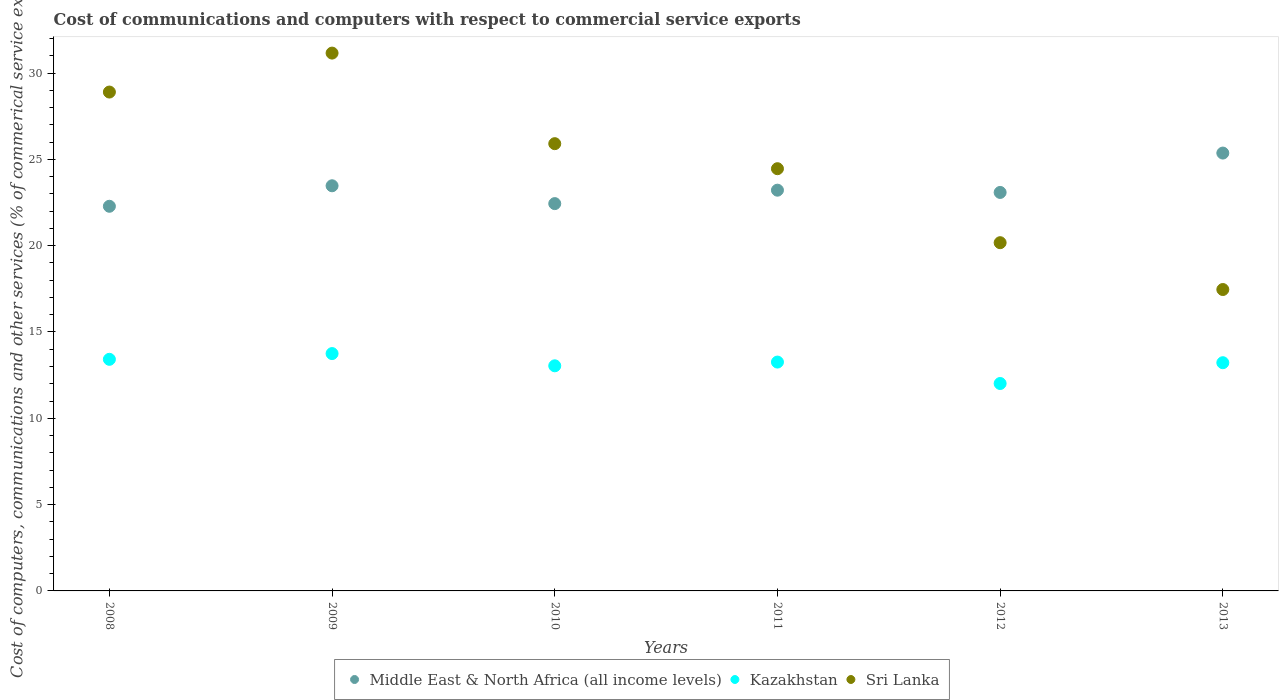Is the number of dotlines equal to the number of legend labels?
Provide a succinct answer. Yes. What is the cost of communications and computers in Kazakhstan in 2010?
Your answer should be very brief. 13.04. Across all years, what is the maximum cost of communications and computers in Sri Lanka?
Provide a short and direct response. 31.16. Across all years, what is the minimum cost of communications and computers in Kazakhstan?
Keep it short and to the point. 12.02. In which year was the cost of communications and computers in Sri Lanka minimum?
Make the answer very short. 2013. What is the total cost of communications and computers in Sri Lanka in the graph?
Ensure brevity in your answer.  148.05. What is the difference between the cost of communications and computers in Sri Lanka in 2010 and that in 2012?
Make the answer very short. 5.74. What is the difference between the cost of communications and computers in Middle East & North Africa (all income levels) in 2010 and the cost of communications and computers in Kazakhstan in 2008?
Keep it short and to the point. 9.02. What is the average cost of communications and computers in Kazakhstan per year?
Your answer should be compact. 13.12. In the year 2010, what is the difference between the cost of communications and computers in Sri Lanka and cost of communications and computers in Middle East & North Africa (all income levels)?
Offer a terse response. 3.47. What is the ratio of the cost of communications and computers in Middle East & North Africa (all income levels) in 2008 to that in 2009?
Your answer should be compact. 0.95. Is the difference between the cost of communications and computers in Sri Lanka in 2011 and 2012 greater than the difference between the cost of communications and computers in Middle East & North Africa (all income levels) in 2011 and 2012?
Offer a terse response. Yes. What is the difference between the highest and the second highest cost of communications and computers in Kazakhstan?
Your answer should be very brief. 0.33. What is the difference between the highest and the lowest cost of communications and computers in Sri Lanka?
Provide a succinct answer. 13.7. In how many years, is the cost of communications and computers in Kazakhstan greater than the average cost of communications and computers in Kazakhstan taken over all years?
Your answer should be very brief. 4. Is the sum of the cost of communications and computers in Kazakhstan in 2009 and 2013 greater than the maximum cost of communications and computers in Sri Lanka across all years?
Give a very brief answer. No. Is it the case that in every year, the sum of the cost of communications and computers in Sri Lanka and cost of communications and computers in Kazakhstan  is greater than the cost of communications and computers in Middle East & North Africa (all income levels)?
Ensure brevity in your answer.  Yes. Does the cost of communications and computers in Sri Lanka monotonically increase over the years?
Your answer should be very brief. No. Is the cost of communications and computers in Kazakhstan strictly greater than the cost of communications and computers in Middle East & North Africa (all income levels) over the years?
Ensure brevity in your answer.  No. Is the cost of communications and computers in Middle East & North Africa (all income levels) strictly less than the cost of communications and computers in Kazakhstan over the years?
Make the answer very short. No. How many dotlines are there?
Keep it short and to the point. 3. How many years are there in the graph?
Provide a short and direct response. 6. What is the difference between two consecutive major ticks on the Y-axis?
Your response must be concise. 5. Does the graph contain any zero values?
Ensure brevity in your answer.  No. What is the title of the graph?
Give a very brief answer. Cost of communications and computers with respect to commercial service exports. What is the label or title of the X-axis?
Give a very brief answer. Years. What is the label or title of the Y-axis?
Give a very brief answer. Cost of computers, communications and other services (% of commerical service exports). What is the Cost of computers, communications and other services (% of commerical service exports) of Middle East & North Africa (all income levels) in 2008?
Provide a succinct answer. 22.28. What is the Cost of computers, communications and other services (% of commerical service exports) in Kazakhstan in 2008?
Offer a very short reply. 13.42. What is the Cost of computers, communications and other services (% of commerical service exports) in Sri Lanka in 2008?
Your response must be concise. 28.9. What is the Cost of computers, communications and other services (% of commerical service exports) in Middle East & North Africa (all income levels) in 2009?
Provide a short and direct response. 23.47. What is the Cost of computers, communications and other services (% of commerical service exports) in Kazakhstan in 2009?
Make the answer very short. 13.75. What is the Cost of computers, communications and other services (% of commerical service exports) in Sri Lanka in 2009?
Provide a succinct answer. 31.16. What is the Cost of computers, communications and other services (% of commerical service exports) of Middle East & North Africa (all income levels) in 2010?
Ensure brevity in your answer.  22.44. What is the Cost of computers, communications and other services (% of commerical service exports) of Kazakhstan in 2010?
Provide a succinct answer. 13.04. What is the Cost of computers, communications and other services (% of commerical service exports) of Sri Lanka in 2010?
Keep it short and to the point. 25.91. What is the Cost of computers, communications and other services (% of commerical service exports) of Middle East & North Africa (all income levels) in 2011?
Make the answer very short. 23.21. What is the Cost of computers, communications and other services (% of commerical service exports) of Kazakhstan in 2011?
Give a very brief answer. 13.26. What is the Cost of computers, communications and other services (% of commerical service exports) of Sri Lanka in 2011?
Your answer should be compact. 24.46. What is the Cost of computers, communications and other services (% of commerical service exports) of Middle East & North Africa (all income levels) in 2012?
Offer a terse response. 23.08. What is the Cost of computers, communications and other services (% of commerical service exports) in Kazakhstan in 2012?
Your answer should be compact. 12.02. What is the Cost of computers, communications and other services (% of commerical service exports) in Sri Lanka in 2012?
Your answer should be very brief. 20.17. What is the Cost of computers, communications and other services (% of commerical service exports) of Middle East & North Africa (all income levels) in 2013?
Offer a terse response. 25.36. What is the Cost of computers, communications and other services (% of commerical service exports) of Kazakhstan in 2013?
Provide a short and direct response. 13.22. What is the Cost of computers, communications and other services (% of commerical service exports) of Sri Lanka in 2013?
Offer a terse response. 17.46. Across all years, what is the maximum Cost of computers, communications and other services (% of commerical service exports) in Middle East & North Africa (all income levels)?
Your answer should be compact. 25.36. Across all years, what is the maximum Cost of computers, communications and other services (% of commerical service exports) of Kazakhstan?
Your answer should be very brief. 13.75. Across all years, what is the maximum Cost of computers, communications and other services (% of commerical service exports) of Sri Lanka?
Offer a very short reply. 31.16. Across all years, what is the minimum Cost of computers, communications and other services (% of commerical service exports) of Middle East & North Africa (all income levels)?
Offer a terse response. 22.28. Across all years, what is the minimum Cost of computers, communications and other services (% of commerical service exports) in Kazakhstan?
Your answer should be very brief. 12.02. Across all years, what is the minimum Cost of computers, communications and other services (% of commerical service exports) in Sri Lanka?
Ensure brevity in your answer.  17.46. What is the total Cost of computers, communications and other services (% of commerical service exports) in Middle East & North Africa (all income levels) in the graph?
Provide a short and direct response. 139.85. What is the total Cost of computers, communications and other services (% of commerical service exports) of Kazakhstan in the graph?
Your response must be concise. 78.7. What is the total Cost of computers, communications and other services (% of commerical service exports) in Sri Lanka in the graph?
Ensure brevity in your answer.  148.05. What is the difference between the Cost of computers, communications and other services (% of commerical service exports) in Middle East & North Africa (all income levels) in 2008 and that in 2009?
Your answer should be very brief. -1.19. What is the difference between the Cost of computers, communications and other services (% of commerical service exports) in Kazakhstan in 2008 and that in 2009?
Keep it short and to the point. -0.33. What is the difference between the Cost of computers, communications and other services (% of commerical service exports) of Sri Lanka in 2008 and that in 2009?
Your response must be concise. -2.26. What is the difference between the Cost of computers, communications and other services (% of commerical service exports) in Middle East & North Africa (all income levels) in 2008 and that in 2010?
Your response must be concise. -0.15. What is the difference between the Cost of computers, communications and other services (% of commerical service exports) of Kazakhstan in 2008 and that in 2010?
Your response must be concise. 0.38. What is the difference between the Cost of computers, communications and other services (% of commerical service exports) in Sri Lanka in 2008 and that in 2010?
Your response must be concise. 2.99. What is the difference between the Cost of computers, communications and other services (% of commerical service exports) of Middle East & North Africa (all income levels) in 2008 and that in 2011?
Offer a very short reply. -0.93. What is the difference between the Cost of computers, communications and other services (% of commerical service exports) in Kazakhstan in 2008 and that in 2011?
Provide a succinct answer. 0.16. What is the difference between the Cost of computers, communications and other services (% of commerical service exports) in Sri Lanka in 2008 and that in 2011?
Your answer should be very brief. 4.44. What is the difference between the Cost of computers, communications and other services (% of commerical service exports) of Middle East & North Africa (all income levels) in 2008 and that in 2012?
Your answer should be compact. -0.8. What is the difference between the Cost of computers, communications and other services (% of commerical service exports) of Kazakhstan in 2008 and that in 2012?
Keep it short and to the point. 1.4. What is the difference between the Cost of computers, communications and other services (% of commerical service exports) of Sri Lanka in 2008 and that in 2012?
Make the answer very short. 8.73. What is the difference between the Cost of computers, communications and other services (% of commerical service exports) in Middle East & North Africa (all income levels) in 2008 and that in 2013?
Your answer should be compact. -3.08. What is the difference between the Cost of computers, communications and other services (% of commerical service exports) of Kazakhstan in 2008 and that in 2013?
Make the answer very short. 0.2. What is the difference between the Cost of computers, communications and other services (% of commerical service exports) in Sri Lanka in 2008 and that in 2013?
Your response must be concise. 11.44. What is the difference between the Cost of computers, communications and other services (% of commerical service exports) of Middle East & North Africa (all income levels) in 2009 and that in 2010?
Your answer should be very brief. 1.03. What is the difference between the Cost of computers, communications and other services (% of commerical service exports) of Kazakhstan in 2009 and that in 2010?
Make the answer very short. 0.71. What is the difference between the Cost of computers, communications and other services (% of commerical service exports) in Sri Lanka in 2009 and that in 2010?
Provide a short and direct response. 5.25. What is the difference between the Cost of computers, communications and other services (% of commerical service exports) in Middle East & North Africa (all income levels) in 2009 and that in 2011?
Keep it short and to the point. 0.25. What is the difference between the Cost of computers, communications and other services (% of commerical service exports) of Kazakhstan in 2009 and that in 2011?
Give a very brief answer. 0.49. What is the difference between the Cost of computers, communications and other services (% of commerical service exports) of Sri Lanka in 2009 and that in 2011?
Ensure brevity in your answer.  6.7. What is the difference between the Cost of computers, communications and other services (% of commerical service exports) of Middle East & North Africa (all income levels) in 2009 and that in 2012?
Keep it short and to the point. 0.39. What is the difference between the Cost of computers, communications and other services (% of commerical service exports) in Kazakhstan in 2009 and that in 2012?
Give a very brief answer. 1.73. What is the difference between the Cost of computers, communications and other services (% of commerical service exports) in Sri Lanka in 2009 and that in 2012?
Your response must be concise. 10.98. What is the difference between the Cost of computers, communications and other services (% of commerical service exports) in Middle East & North Africa (all income levels) in 2009 and that in 2013?
Provide a short and direct response. -1.89. What is the difference between the Cost of computers, communications and other services (% of commerical service exports) in Kazakhstan in 2009 and that in 2013?
Give a very brief answer. 0.53. What is the difference between the Cost of computers, communications and other services (% of commerical service exports) of Sri Lanka in 2009 and that in 2013?
Your answer should be very brief. 13.7. What is the difference between the Cost of computers, communications and other services (% of commerical service exports) of Middle East & North Africa (all income levels) in 2010 and that in 2011?
Give a very brief answer. -0.78. What is the difference between the Cost of computers, communications and other services (% of commerical service exports) of Kazakhstan in 2010 and that in 2011?
Keep it short and to the point. -0.22. What is the difference between the Cost of computers, communications and other services (% of commerical service exports) in Sri Lanka in 2010 and that in 2011?
Your answer should be compact. 1.45. What is the difference between the Cost of computers, communications and other services (% of commerical service exports) in Middle East & North Africa (all income levels) in 2010 and that in 2012?
Your answer should be compact. -0.65. What is the difference between the Cost of computers, communications and other services (% of commerical service exports) of Kazakhstan in 2010 and that in 2012?
Offer a terse response. 1.03. What is the difference between the Cost of computers, communications and other services (% of commerical service exports) of Sri Lanka in 2010 and that in 2012?
Make the answer very short. 5.74. What is the difference between the Cost of computers, communications and other services (% of commerical service exports) of Middle East & North Africa (all income levels) in 2010 and that in 2013?
Your response must be concise. -2.93. What is the difference between the Cost of computers, communications and other services (% of commerical service exports) of Kazakhstan in 2010 and that in 2013?
Your response must be concise. -0.18. What is the difference between the Cost of computers, communications and other services (% of commerical service exports) of Sri Lanka in 2010 and that in 2013?
Provide a succinct answer. 8.45. What is the difference between the Cost of computers, communications and other services (% of commerical service exports) of Middle East & North Africa (all income levels) in 2011 and that in 2012?
Your answer should be very brief. 0.13. What is the difference between the Cost of computers, communications and other services (% of commerical service exports) in Kazakhstan in 2011 and that in 2012?
Keep it short and to the point. 1.24. What is the difference between the Cost of computers, communications and other services (% of commerical service exports) in Sri Lanka in 2011 and that in 2012?
Give a very brief answer. 4.29. What is the difference between the Cost of computers, communications and other services (% of commerical service exports) of Middle East & North Africa (all income levels) in 2011 and that in 2013?
Give a very brief answer. -2.15. What is the difference between the Cost of computers, communications and other services (% of commerical service exports) in Kazakhstan in 2011 and that in 2013?
Provide a short and direct response. 0.04. What is the difference between the Cost of computers, communications and other services (% of commerical service exports) in Sri Lanka in 2011 and that in 2013?
Provide a short and direct response. 7. What is the difference between the Cost of computers, communications and other services (% of commerical service exports) in Middle East & North Africa (all income levels) in 2012 and that in 2013?
Give a very brief answer. -2.28. What is the difference between the Cost of computers, communications and other services (% of commerical service exports) of Kazakhstan in 2012 and that in 2013?
Your response must be concise. -1.2. What is the difference between the Cost of computers, communications and other services (% of commerical service exports) of Sri Lanka in 2012 and that in 2013?
Provide a succinct answer. 2.71. What is the difference between the Cost of computers, communications and other services (% of commerical service exports) in Middle East & North Africa (all income levels) in 2008 and the Cost of computers, communications and other services (% of commerical service exports) in Kazakhstan in 2009?
Offer a very short reply. 8.53. What is the difference between the Cost of computers, communications and other services (% of commerical service exports) in Middle East & North Africa (all income levels) in 2008 and the Cost of computers, communications and other services (% of commerical service exports) in Sri Lanka in 2009?
Your answer should be very brief. -8.87. What is the difference between the Cost of computers, communications and other services (% of commerical service exports) in Kazakhstan in 2008 and the Cost of computers, communications and other services (% of commerical service exports) in Sri Lanka in 2009?
Provide a short and direct response. -17.74. What is the difference between the Cost of computers, communications and other services (% of commerical service exports) of Middle East & North Africa (all income levels) in 2008 and the Cost of computers, communications and other services (% of commerical service exports) of Kazakhstan in 2010?
Offer a terse response. 9.24. What is the difference between the Cost of computers, communications and other services (% of commerical service exports) in Middle East & North Africa (all income levels) in 2008 and the Cost of computers, communications and other services (% of commerical service exports) in Sri Lanka in 2010?
Make the answer very short. -3.63. What is the difference between the Cost of computers, communications and other services (% of commerical service exports) of Kazakhstan in 2008 and the Cost of computers, communications and other services (% of commerical service exports) of Sri Lanka in 2010?
Make the answer very short. -12.49. What is the difference between the Cost of computers, communications and other services (% of commerical service exports) of Middle East & North Africa (all income levels) in 2008 and the Cost of computers, communications and other services (% of commerical service exports) of Kazakhstan in 2011?
Your response must be concise. 9.03. What is the difference between the Cost of computers, communications and other services (% of commerical service exports) of Middle East & North Africa (all income levels) in 2008 and the Cost of computers, communications and other services (% of commerical service exports) of Sri Lanka in 2011?
Keep it short and to the point. -2.18. What is the difference between the Cost of computers, communications and other services (% of commerical service exports) of Kazakhstan in 2008 and the Cost of computers, communications and other services (% of commerical service exports) of Sri Lanka in 2011?
Give a very brief answer. -11.04. What is the difference between the Cost of computers, communications and other services (% of commerical service exports) of Middle East & North Africa (all income levels) in 2008 and the Cost of computers, communications and other services (% of commerical service exports) of Kazakhstan in 2012?
Offer a very short reply. 10.27. What is the difference between the Cost of computers, communications and other services (% of commerical service exports) of Middle East & North Africa (all income levels) in 2008 and the Cost of computers, communications and other services (% of commerical service exports) of Sri Lanka in 2012?
Make the answer very short. 2.11. What is the difference between the Cost of computers, communications and other services (% of commerical service exports) of Kazakhstan in 2008 and the Cost of computers, communications and other services (% of commerical service exports) of Sri Lanka in 2012?
Your answer should be very brief. -6.76. What is the difference between the Cost of computers, communications and other services (% of commerical service exports) in Middle East & North Africa (all income levels) in 2008 and the Cost of computers, communications and other services (% of commerical service exports) in Kazakhstan in 2013?
Offer a very short reply. 9.06. What is the difference between the Cost of computers, communications and other services (% of commerical service exports) of Middle East & North Africa (all income levels) in 2008 and the Cost of computers, communications and other services (% of commerical service exports) of Sri Lanka in 2013?
Make the answer very short. 4.82. What is the difference between the Cost of computers, communications and other services (% of commerical service exports) of Kazakhstan in 2008 and the Cost of computers, communications and other services (% of commerical service exports) of Sri Lanka in 2013?
Provide a succinct answer. -4.04. What is the difference between the Cost of computers, communications and other services (% of commerical service exports) of Middle East & North Africa (all income levels) in 2009 and the Cost of computers, communications and other services (% of commerical service exports) of Kazakhstan in 2010?
Give a very brief answer. 10.43. What is the difference between the Cost of computers, communications and other services (% of commerical service exports) of Middle East & North Africa (all income levels) in 2009 and the Cost of computers, communications and other services (% of commerical service exports) of Sri Lanka in 2010?
Make the answer very short. -2.44. What is the difference between the Cost of computers, communications and other services (% of commerical service exports) of Kazakhstan in 2009 and the Cost of computers, communications and other services (% of commerical service exports) of Sri Lanka in 2010?
Your response must be concise. -12.16. What is the difference between the Cost of computers, communications and other services (% of commerical service exports) of Middle East & North Africa (all income levels) in 2009 and the Cost of computers, communications and other services (% of commerical service exports) of Kazakhstan in 2011?
Your answer should be very brief. 10.21. What is the difference between the Cost of computers, communications and other services (% of commerical service exports) in Middle East & North Africa (all income levels) in 2009 and the Cost of computers, communications and other services (% of commerical service exports) in Sri Lanka in 2011?
Your answer should be compact. -0.99. What is the difference between the Cost of computers, communications and other services (% of commerical service exports) of Kazakhstan in 2009 and the Cost of computers, communications and other services (% of commerical service exports) of Sri Lanka in 2011?
Provide a succinct answer. -10.71. What is the difference between the Cost of computers, communications and other services (% of commerical service exports) in Middle East & North Africa (all income levels) in 2009 and the Cost of computers, communications and other services (% of commerical service exports) in Kazakhstan in 2012?
Provide a short and direct response. 11.45. What is the difference between the Cost of computers, communications and other services (% of commerical service exports) of Middle East & North Africa (all income levels) in 2009 and the Cost of computers, communications and other services (% of commerical service exports) of Sri Lanka in 2012?
Offer a terse response. 3.3. What is the difference between the Cost of computers, communications and other services (% of commerical service exports) in Kazakhstan in 2009 and the Cost of computers, communications and other services (% of commerical service exports) in Sri Lanka in 2012?
Provide a succinct answer. -6.42. What is the difference between the Cost of computers, communications and other services (% of commerical service exports) in Middle East & North Africa (all income levels) in 2009 and the Cost of computers, communications and other services (% of commerical service exports) in Kazakhstan in 2013?
Offer a very short reply. 10.25. What is the difference between the Cost of computers, communications and other services (% of commerical service exports) of Middle East & North Africa (all income levels) in 2009 and the Cost of computers, communications and other services (% of commerical service exports) of Sri Lanka in 2013?
Your response must be concise. 6.01. What is the difference between the Cost of computers, communications and other services (% of commerical service exports) of Kazakhstan in 2009 and the Cost of computers, communications and other services (% of commerical service exports) of Sri Lanka in 2013?
Your answer should be compact. -3.71. What is the difference between the Cost of computers, communications and other services (% of commerical service exports) in Middle East & North Africa (all income levels) in 2010 and the Cost of computers, communications and other services (% of commerical service exports) in Kazakhstan in 2011?
Give a very brief answer. 9.18. What is the difference between the Cost of computers, communications and other services (% of commerical service exports) in Middle East & North Africa (all income levels) in 2010 and the Cost of computers, communications and other services (% of commerical service exports) in Sri Lanka in 2011?
Your answer should be very brief. -2.02. What is the difference between the Cost of computers, communications and other services (% of commerical service exports) in Kazakhstan in 2010 and the Cost of computers, communications and other services (% of commerical service exports) in Sri Lanka in 2011?
Ensure brevity in your answer.  -11.42. What is the difference between the Cost of computers, communications and other services (% of commerical service exports) of Middle East & North Africa (all income levels) in 2010 and the Cost of computers, communications and other services (% of commerical service exports) of Kazakhstan in 2012?
Your answer should be very brief. 10.42. What is the difference between the Cost of computers, communications and other services (% of commerical service exports) of Middle East & North Africa (all income levels) in 2010 and the Cost of computers, communications and other services (% of commerical service exports) of Sri Lanka in 2012?
Your response must be concise. 2.26. What is the difference between the Cost of computers, communications and other services (% of commerical service exports) in Kazakhstan in 2010 and the Cost of computers, communications and other services (% of commerical service exports) in Sri Lanka in 2012?
Keep it short and to the point. -7.13. What is the difference between the Cost of computers, communications and other services (% of commerical service exports) in Middle East & North Africa (all income levels) in 2010 and the Cost of computers, communications and other services (% of commerical service exports) in Kazakhstan in 2013?
Your response must be concise. 9.22. What is the difference between the Cost of computers, communications and other services (% of commerical service exports) in Middle East & North Africa (all income levels) in 2010 and the Cost of computers, communications and other services (% of commerical service exports) in Sri Lanka in 2013?
Your response must be concise. 4.98. What is the difference between the Cost of computers, communications and other services (% of commerical service exports) of Kazakhstan in 2010 and the Cost of computers, communications and other services (% of commerical service exports) of Sri Lanka in 2013?
Keep it short and to the point. -4.42. What is the difference between the Cost of computers, communications and other services (% of commerical service exports) of Middle East & North Africa (all income levels) in 2011 and the Cost of computers, communications and other services (% of commerical service exports) of Kazakhstan in 2012?
Provide a succinct answer. 11.2. What is the difference between the Cost of computers, communications and other services (% of commerical service exports) in Middle East & North Africa (all income levels) in 2011 and the Cost of computers, communications and other services (% of commerical service exports) in Sri Lanka in 2012?
Make the answer very short. 3.04. What is the difference between the Cost of computers, communications and other services (% of commerical service exports) of Kazakhstan in 2011 and the Cost of computers, communications and other services (% of commerical service exports) of Sri Lanka in 2012?
Your answer should be very brief. -6.92. What is the difference between the Cost of computers, communications and other services (% of commerical service exports) in Middle East & North Africa (all income levels) in 2011 and the Cost of computers, communications and other services (% of commerical service exports) in Kazakhstan in 2013?
Your answer should be compact. 9.99. What is the difference between the Cost of computers, communications and other services (% of commerical service exports) in Middle East & North Africa (all income levels) in 2011 and the Cost of computers, communications and other services (% of commerical service exports) in Sri Lanka in 2013?
Make the answer very short. 5.76. What is the difference between the Cost of computers, communications and other services (% of commerical service exports) in Kazakhstan in 2011 and the Cost of computers, communications and other services (% of commerical service exports) in Sri Lanka in 2013?
Your answer should be compact. -4.2. What is the difference between the Cost of computers, communications and other services (% of commerical service exports) of Middle East & North Africa (all income levels) in 2012 and the Cost of computers, communications and other services (% of commerical service exports) of Kazakhstan in 2013?
Offer a terse response. 9.86. What is the difference between the Cost of computers, communications and other services (% of commerical service exports) in Middle East & North Africa (all income levels) in 2012 and the Cost of computers, communications and other services (% of commerical service exports) in Sri Lanka in 2013?
Your answer should be very brief. 5.62. What is the difference between the Cost of computers, communications and other services (% of commerical service exports) of Kazakhstan in 2012 and the Cost of computers, communications and other services (% of commerical service exports) of Sri Lanka in 2013?
Your answer should be very brief. -5.44. What is the average Cost of computers, communications and other services (% of commerical service exports) of Middle East & North Africa (all income levels) per year?
Offer a very short reply. 23.31. What is the average Cost of computers, communications and other services (% of commerical service exports) of Kazakhstan per year?
Provide a succinct answer. 13.12. What is the average Cost of computers, communications and other services (% of commerical service exports) in Sri Lanka per year?
Your answer should be compact. 24.68. In the year 2008, what is the difference between the Cost of computers, communications and other services (% of commerical service exports) of Middle East & North Africa (all income levels) and Cost of computers, communications and other services (% of commerical service exports) of Kazakhstan?
Give a very brief answer. 8.87. In the year 2008, what is the difference between the Cost of computers, communications and other services (% of commerical service exports) in Middle East & North Africa (all income levels) and Cost of computers, communications and other services (% of commerical service exports) in Sri Lanka?
Keep it short and to the point. -6.62. In the year 2008, what is the difference between the Cost of computers, communications and other services (% of commerical service exports) of Kazakhstan and Cost of computers, communications and other services (% of commerical service exports) of Sri Lanka?
Provide a succinct answer. -15.48. In the year 2009, what is the difference between the Cost of computers, communications and other services (% of commerical service exports) in Middle East & North Africa (all income levels) and Cost of computers, communications and other services (% of commerical service exports) in Kazakhstan?
Provide a short and direct response. 9.72. In the year 2009, what is the difference between the Cost of computers, communications and other services (% of commerical service exports) in Middle East & North Africa (all income levels) and Cost of computers, communications and other services (% of commerical service exports) in Sri Lanka?
Offer a terse response. -7.69. In the year 2009, what is the difference between the Cost of computers, communications and other services (% of commerical service exports) in Kazakhstan and Cost of computers, communications and other services (% of commerical service exports) in Sri Lanka?
Your answer should be compact. -17.41. In the year 2010, what is the difference between the Cost of computers, communications and other services (% of commerical service exports) of Middle East & North Africa (all income levels) and Cost of computers, communications and other services (% of commerical service exports) of Kazakhstan?
Give a very brief answer. 9.4. In the year 2010, what is the difference between the Cost of computers, communications and other services (% of commerical service exports) in Middle East & North Africa (all income levels) and Cost of computers, communications and other services (% of commerical service exports) in Sri Lanka?
Provide a succinct answer. -3.47. In the year 2010, what is the difference between the Cost of computers, communications and other services (% of commerical service exports) in Kazakhstan and Cost of computers, communications and other services (% of commerical service exports) in Sri Lanka?
Keep it short and to the point. -12.87. In the year 2011, what is the difference between the Cost of computers, communications and other services (% of commerical service exports) in Middle East & North Africa (all income levels) and Cost of computers, communications and other services (% of commerical service exports) in Kazakhstan?
Provide a succinct answer. 9.96. In the year 2011, what is the difference between the Cost of computers, communications and other services (% of commerical service exports) of Middle East & North Africa (all income levels) and Cost of computers, communications and other services (% of commerical service exports) of Sri Lanka?
Provide a short and direct response. -1.24. In the year 2011, what is the difference between the Cost of computers, communications and other services (% of commerical service exports) in Kazakhstan and Cost of computers, communications and other services (% of commerical service exports) in Sri Lanka?
Offer a very short reply. -11.2. In the year 2012, what is the difference between the Cost of computers, communications and other services (% of commerical service exports) in Middle East & North Africa (all income levels) and Cost of computers, communications and other services (% of commerical service exports) in Kazakhstan?
Provide a succinct answer. 11.07. In the year 2012, what is the difference between the Cost of computers, communications and other services (% of commerical service exports) in Middle East & North Africa (all income levels) and Cost of computers, communications and other services (% of commerical service exports) in Sri Lanka?
Offer a terse response. 2.91. In the year 2012, what is the difference between the Cost of computers, communications and other services (% of commerical service exports) in Kazakhstan and Cost of computers, communications and other services (% of commerical service exports) in Sri Lanka?
Ensure brevity in your answer.  -8.16. In the year 2013, what is the difference between the Cost of computers, communications and other services (% of commerical service exports) of Middle East & North Africa (all income levels) and Cost of computers, communications and other services (% of commerical service exports) of Kazakhstan?
Offer a terse response. 12.14. In the year 2013, what is the difference between the Cost of computers, communications and other services (% of commerical service exports) of Middle East & North Africa (all income levels) and Cost of computers, communications and other services (% of commerical service exports) of Sri Lanka?
Provide a succinct answer. 7.9. In the year 2013, what is the difference between the Cost of computers, communications and other services (% of commerical service exports) in Kazakhstan and Cost of computers, communications and other services (% of commerical service exports) in Sri Lanka?
Give a very brief answer. -4.24. What is the ratio of the Cost of computers, communications and other services (% of commerical service exports) of Middle East & North Africa (all income levels) in 2008 to that in 2009?
Give a very brief answer. 0.95. What is the ratio of the Cost of computers, communications and other services (% of commerical service exports) in Kazakhstan in 2008 to that in 2009?
Provide a succinct answer. 0.98. What is the ratio of the Cost of computers, communications and other services (% of commerical service exports) in Sri Lanka in 2008 to that in 2009?
Give a very brief answer. 0.93. What is the ratio of the Cost of computers, communications and other services (% of commerical service exports) of Kazakhstan in 2008 to that in 2010?
Ensure brevity in your answer.  1.03. What is the ratio of the Cost of computers, communications and other services (% of commerical service exports) in Sri Lanka in 2008 to that in 2010?
Your answer should be very brief. 1.12. What is the ratio of the Cost of computers, communications and other services (% of commerical service exports) in Middle East & North Africa (all income levels) in 2008 to that in 2011?
Provide a succinct answer. 0.96. What is the ratio of the Cost of computers, communications and other services (% of commerical service exports) in Kazakhstan in 2008 to that in 2011?
Your answer should be compact. 1.01. What is the ratio of the Cost of computers, communications and other services (% of commerical service exports) in Sri Lanka in 2008 to that in 2011?
Provide a succinct answer. 1.18. What is the ratio of the Cost of computers, communications and other services (% of commerical service exports) of Middle East & North Africa (all income levels) in 2008 to that in 2012?
Make the answer very short. 0.97. What is the ratio of the Cost of computers, communications and other services (% of commerical service exports) in Kazakhstan in 2008 to that in 2012?
Make the answer very short. 1.12. What is the ratio of the Cost of computers, communications and other services (% of commerical service exports) in Sri Lanka in 2008 to that in 2012?
Your answer should be compact. 1.43. What is the ratio of the Cost of computers, communications and other services (% of commerical service exports) of Middle East & North Africa (all income levels) in 2008 to that in 2013?
Keep it short and to the point. 0.88. What is the ratio of the Cost of computers, communications and other services (% of commerical service exports) of Kazakhstan in 2008 to that in 2013?
Offer a very short reply. 1.01. What is the ratio of the Cost of computers, communications and other services (% of commerical service exports) in Sri Lanka in 2008 to that in 2013?
Your answer should be compact. 1.66. What is the ratio of the Cost of computers, communications and other services (% of commerical service exports) of Middle East & North Africa (all income levels) in 2009 to that in 2010?
Your answer should be compact. 1.05. What is the ratio of the Cost of computers, communications and other services (% of commerical service exports) in Kazakhstan in 2009 to that in 2010?
Make the answer very short. 1.05. What is the ratio of the Cost of computers, communications and other services (% of commerical service exports) of Sri Lanka in 2009 to that in 2010?
Make the answer very short. 1.2. What is the ratio of the Cost of computers, communications and other services (% of commerical service exports) of Middle East & North Africa (all income levels) in 2009 to that in 2011?
Offer a terse response. 1.01. What is the ratio of the Cost of computers, communications and other services (% of commerical service exports) in Kazakhstan in 2009 to that in 2011?
Provide a succinct answer. 1.04. What is the ratio of the Cost of computers, communications and other services (% of commerical service exports) in Sri Lanka in 2009 to that in 2011?
Offer a terse response. 1.27. What is the ratio of the Cost of computers, communications and other services (% of commerical service exports) of Middle East & North Africa (all income levels) in 2009 to that in 2012?
Keep it short and to the point. 1.02. What is the ratio of the Cost of computers, communications and other services (% of commerical service exports) of Kazakhstan in 2009 to that in 2012?
Your response must be concise. 1.14. What is the ratio of the Cost of computers, communications and other services (% of commerical service exports) of Sri Lanka in 2009 to that in 2012?
Make the answer very short. 1.54. What is the ratio of the Cost of computers, communications and other services (% of commerical service exports) of Middle East & North Africa (all income levels) in 2009 to that in 2013?
Provide a short and direct response. 0.93. What is the ratio of the Cost of computers, communications and other services (% of commerical service exports) in Sri Lanka in 2009 to that in 2013?
Your answer should be compact. 1.78. What is the ratio of the Cost of computers, communications and other services (% of commerical service exports) of Middle East & North Africa (all income levels) in 2010 to that in 2011?
Offer a terse response. 0.97. What is the ratio of the Cost of computers, communications and other services (% of commerical service exports) in Kazakhstan in 2010 to that in 2011?
Offer a very short reply. 0.98. What is the ratio of the Cost of computers, communications and other services (% of commerical service exports) of Sri Lanka in 2010 to that in 2011?
Keep it short and to the point. 1.06. What is the ratio of the Cost of computers, communications and other services (% of commerical service exports) in Middle East & North Africa (all income levels) in 2010 to that in 2012?
Offer a terse response. 0.97. What is the ratio of the Cost of computers, communications and other services (% of commerical service exports) in Kazakhstan in 2010 to that in 2012?
Offer a terse response. 1.09. What is the ratio of the Cost of computers, communications and other services (% of commerical service exports) in Sri Lanka in 2010 to that in 2012?
Offer a terse response. 1.28. What is the ratio of the Cost of computers, communications and other services (% of commerical service exports) of Middle East & North Africa (all income levels) in 2010 to that in 2013?
Make the answer very short. 0.88. What is the ratio of the Cost of computers, communications and other services (% of commerical service exports) in Kazakhstan in 2010 to that in 2013?
Offer a very short reply. 0.99. What is the ratio of the Cost of computers, communications and other services (% of commerical service exports) of Sri Lanka in 2010 to that in 2013?
Your answer should be very brief. 1.48. What is the ratio of the Cost of computers, communications and other services (% of commerical service exports) of Middle East & North Africa (all income levels) in 2011 to that in 2012?
Your response must be concise. 1.01. What is the ratio of the Cost of computers, communications and other services (% of commerical service exports) in Kazakhstan in 2011 to that in 2012?
Your answer should be very brief. 1.1. What is the ratio of the Cost of computers, communications and other services (% of commerical service exports) of Sri Lanka in 2011 to that in 2012?
Your response must be concise. 1.21. What is the ratio of the Cost of computers, communications and other services (% of commerical service exports) of Middle East & North Africa (all income levels) in 2011 to that in 2013?
Provide a succinct answer. 0.92. What is the ratio of the Cost of computers, communications and other services (% of commerical service exports) in Sri Lanka in 2011 to that in 2013?
Offer a very short reply. 1.4. What is the ratio of the Cost of computers, communications and other services (% of commerical service exports) of Middle East & North Africa (all income levels) in 2012 to that in 2013?
Your answer should be compact. 0.91. What is the ratio of the Cost of computers, communications and other services (% of commerical service exports) of Kazakhstan in 2012 to that in 2013?
Provide a short and direct response. 0.91. What is the ratio of the Cost of computers, communications and other services (% of commerical service exports) of Sri Lanka in 2012 to that in 2013?
Offer a terse response. 1.16. What is the difference between the highest and the second highest Cost of computers, communications and other services (% of commerical service exports) in Middle East & North Africa (all income levels)?
Your answer should be compact. 1.89. What is the difference between the highest and the second highest Cost of computers, communications and other services (% of commerical service exports) of Kazakhstan?
Your answer should be compact. 0.33. What is the difference between the highest and the second highest Cost of computers, communications and other services (% of commerical service exports) in Sri Lanka?
Keep it short and to the point. 2.26. What is the difference between the highest and the lowest Cost of computers, communications and other services (% of commerical service exports) of Middle East & North Africa (all income levels)?
Your answer should be very brief. 3.08. What is the difference between the highest and the lowest Cost of computers, communications and other services (% of commerical service exports) in Kazakhstan?
Provide a short and direct response. 1.73. What is the difference between the highest and the lowest Cost of computers, communications and other services (% of commerical service exports) of Sri Lanka?
Give a very brief answer. 13.7. 